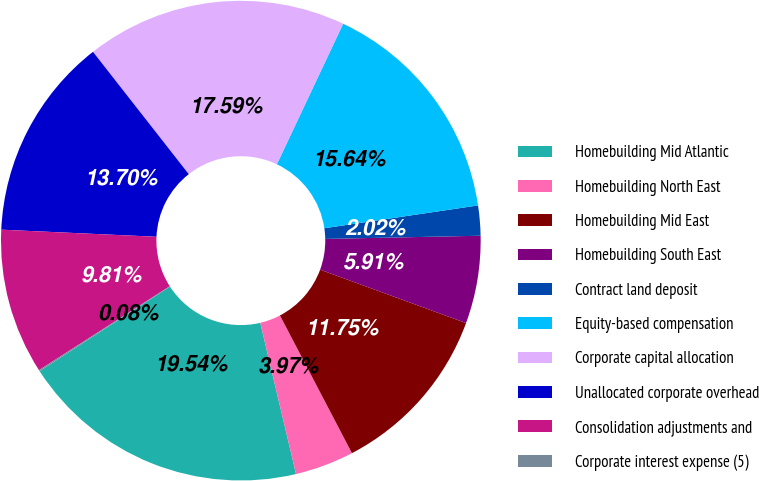Convert chart to OTSL. <chart><loc_0><loc_0><loc_500><loc_500><pie_chart><fcel>Homebuilding Mid Atlantic<fcel>Homebuilding North East<fcel>Homebuilding Mid East<fcel>Homebuilding South East<fcel>Contract land deposit<fcel>Equity-based compensation<fcel>Corporate capital allocation<fcel>Unallocated corporate overhead<fcel>Consolidation adjustments and<fcel>Corporate interest expense (5)<nl><fcel>19.54%<fcel>3.97%<fcel>11.75%<fcel>5.91%<fcel>2.02%<fcel>15.64%<fcel>17.59%<fcel>13.7%<fcel>9.81%<fcel>0.08%<nl></chart> 